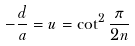Convert formula to latex. <formula><loc_0><loc_0><loc_500><loc_500>- \frac { d } { a } = u = \cot ^ { 2 } \frac { \pi } { 2 n }</formula> 